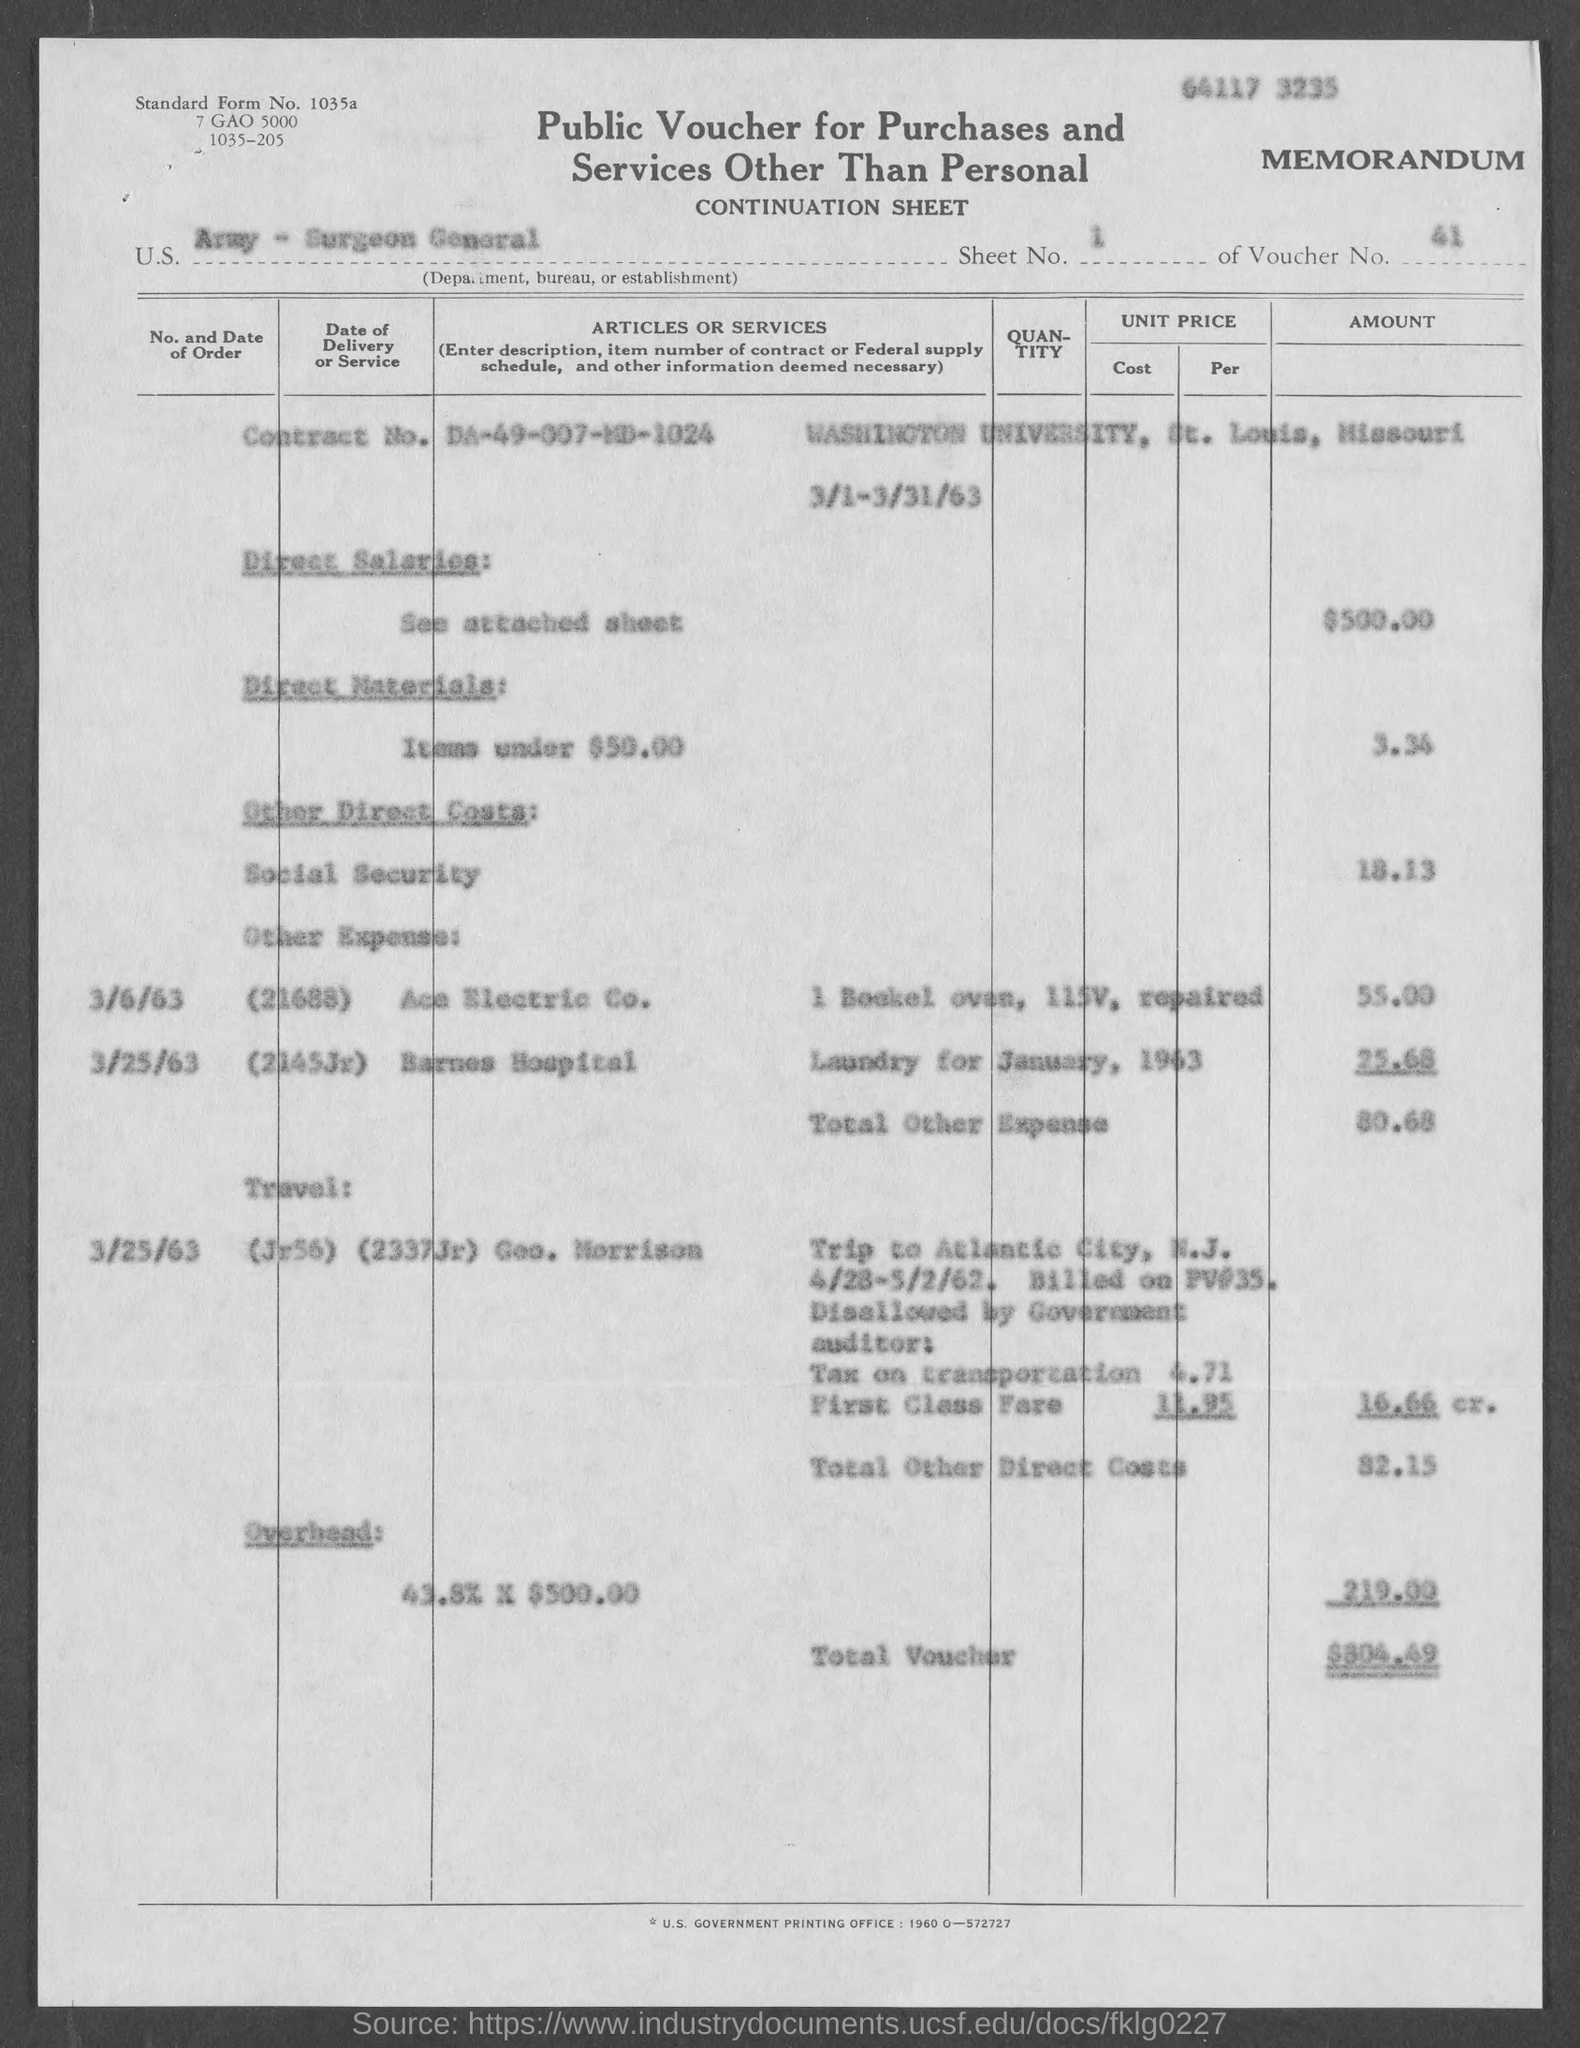Give some essential details in this illustration. The voucher number mentioned in the document is 41. The standard form number listed in the voucher is 1035a.. The direct salaries cost mentioned in the voucher is $500.00. The voucher indicates that the U.S. Department, Bureau, or Establishment mentioned is the Army - Surgeon General. What sheet number is mentioned in the voucher? 